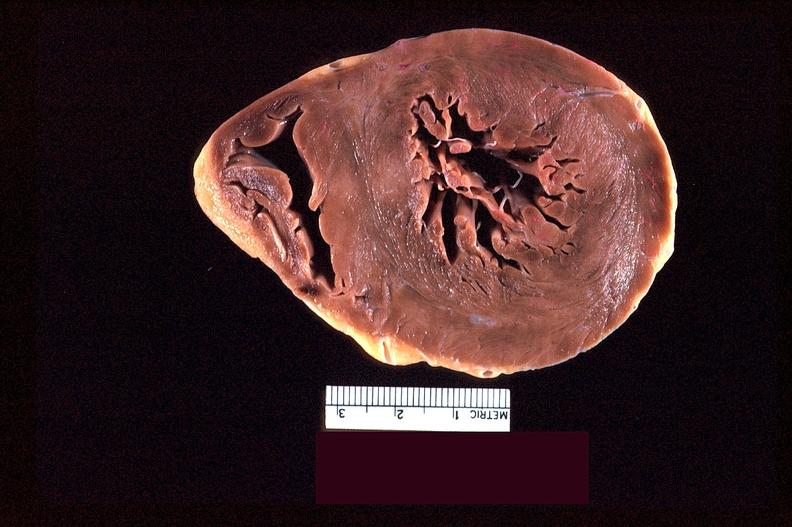where is this?
Answer the question using a single word or phrase. Heart 